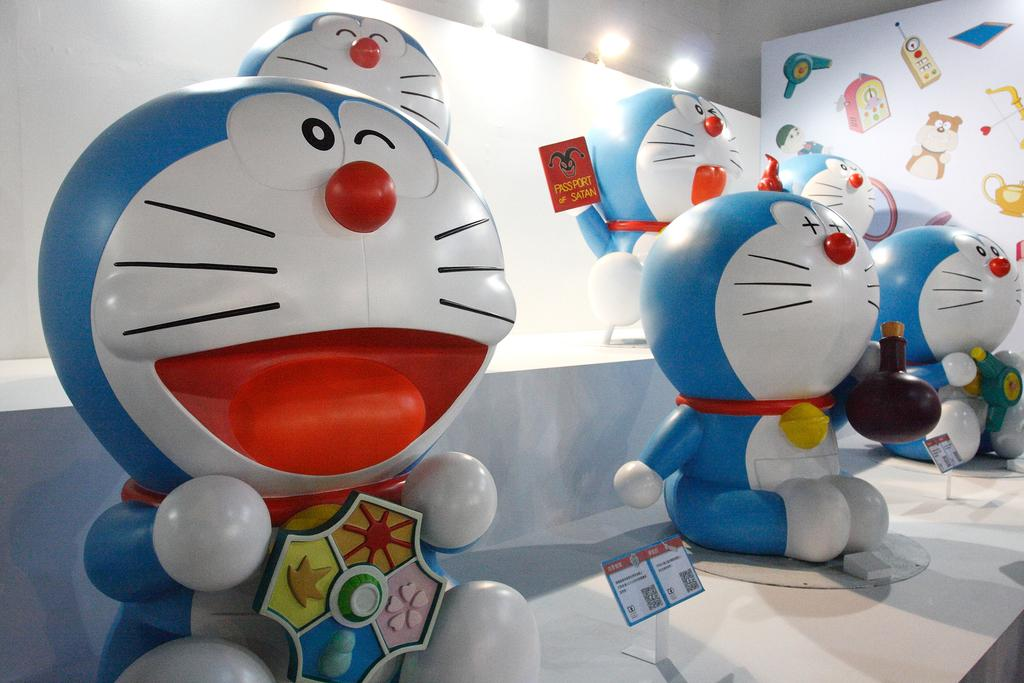What objects can be seen on a shelf in the image? There are toys on a shelf in the image. What is on the right side wall in the image? There are stickers on the right side wall in the image. What is behind the stickers on the wall in the image? There are lights behind the stickers on the wall in the image. Is there a throne visible in the image? No, there is no throne present in the image. What type of hat is being worn by the stickers on the wall? There are no hats present in the image, as the stickers are not depicted as wearing any accessories. 